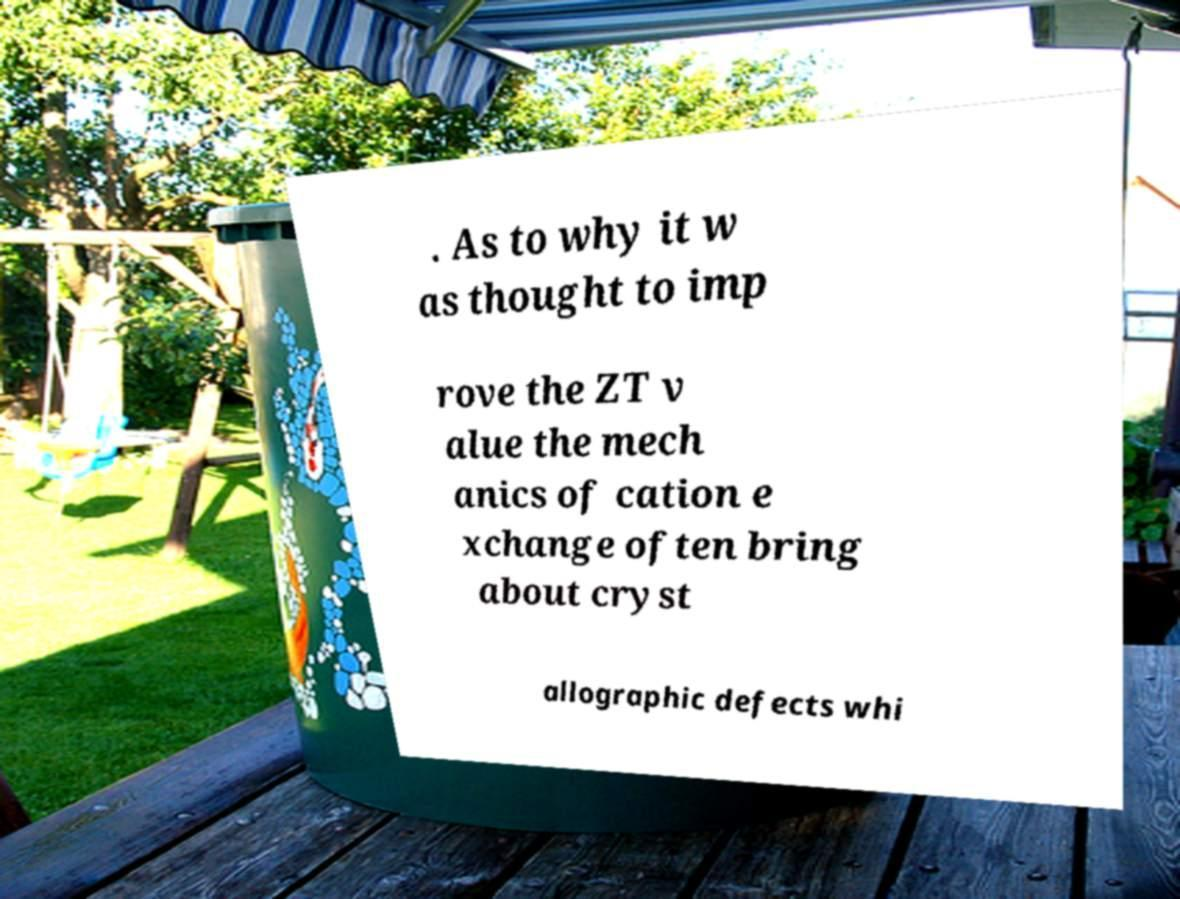Can you accurately transcribe the text from the provided image for me? . As to why it w as thought to imp rove the ZT v alue the mech anics of cation e xchange often bring about cryst allographic defects whi 